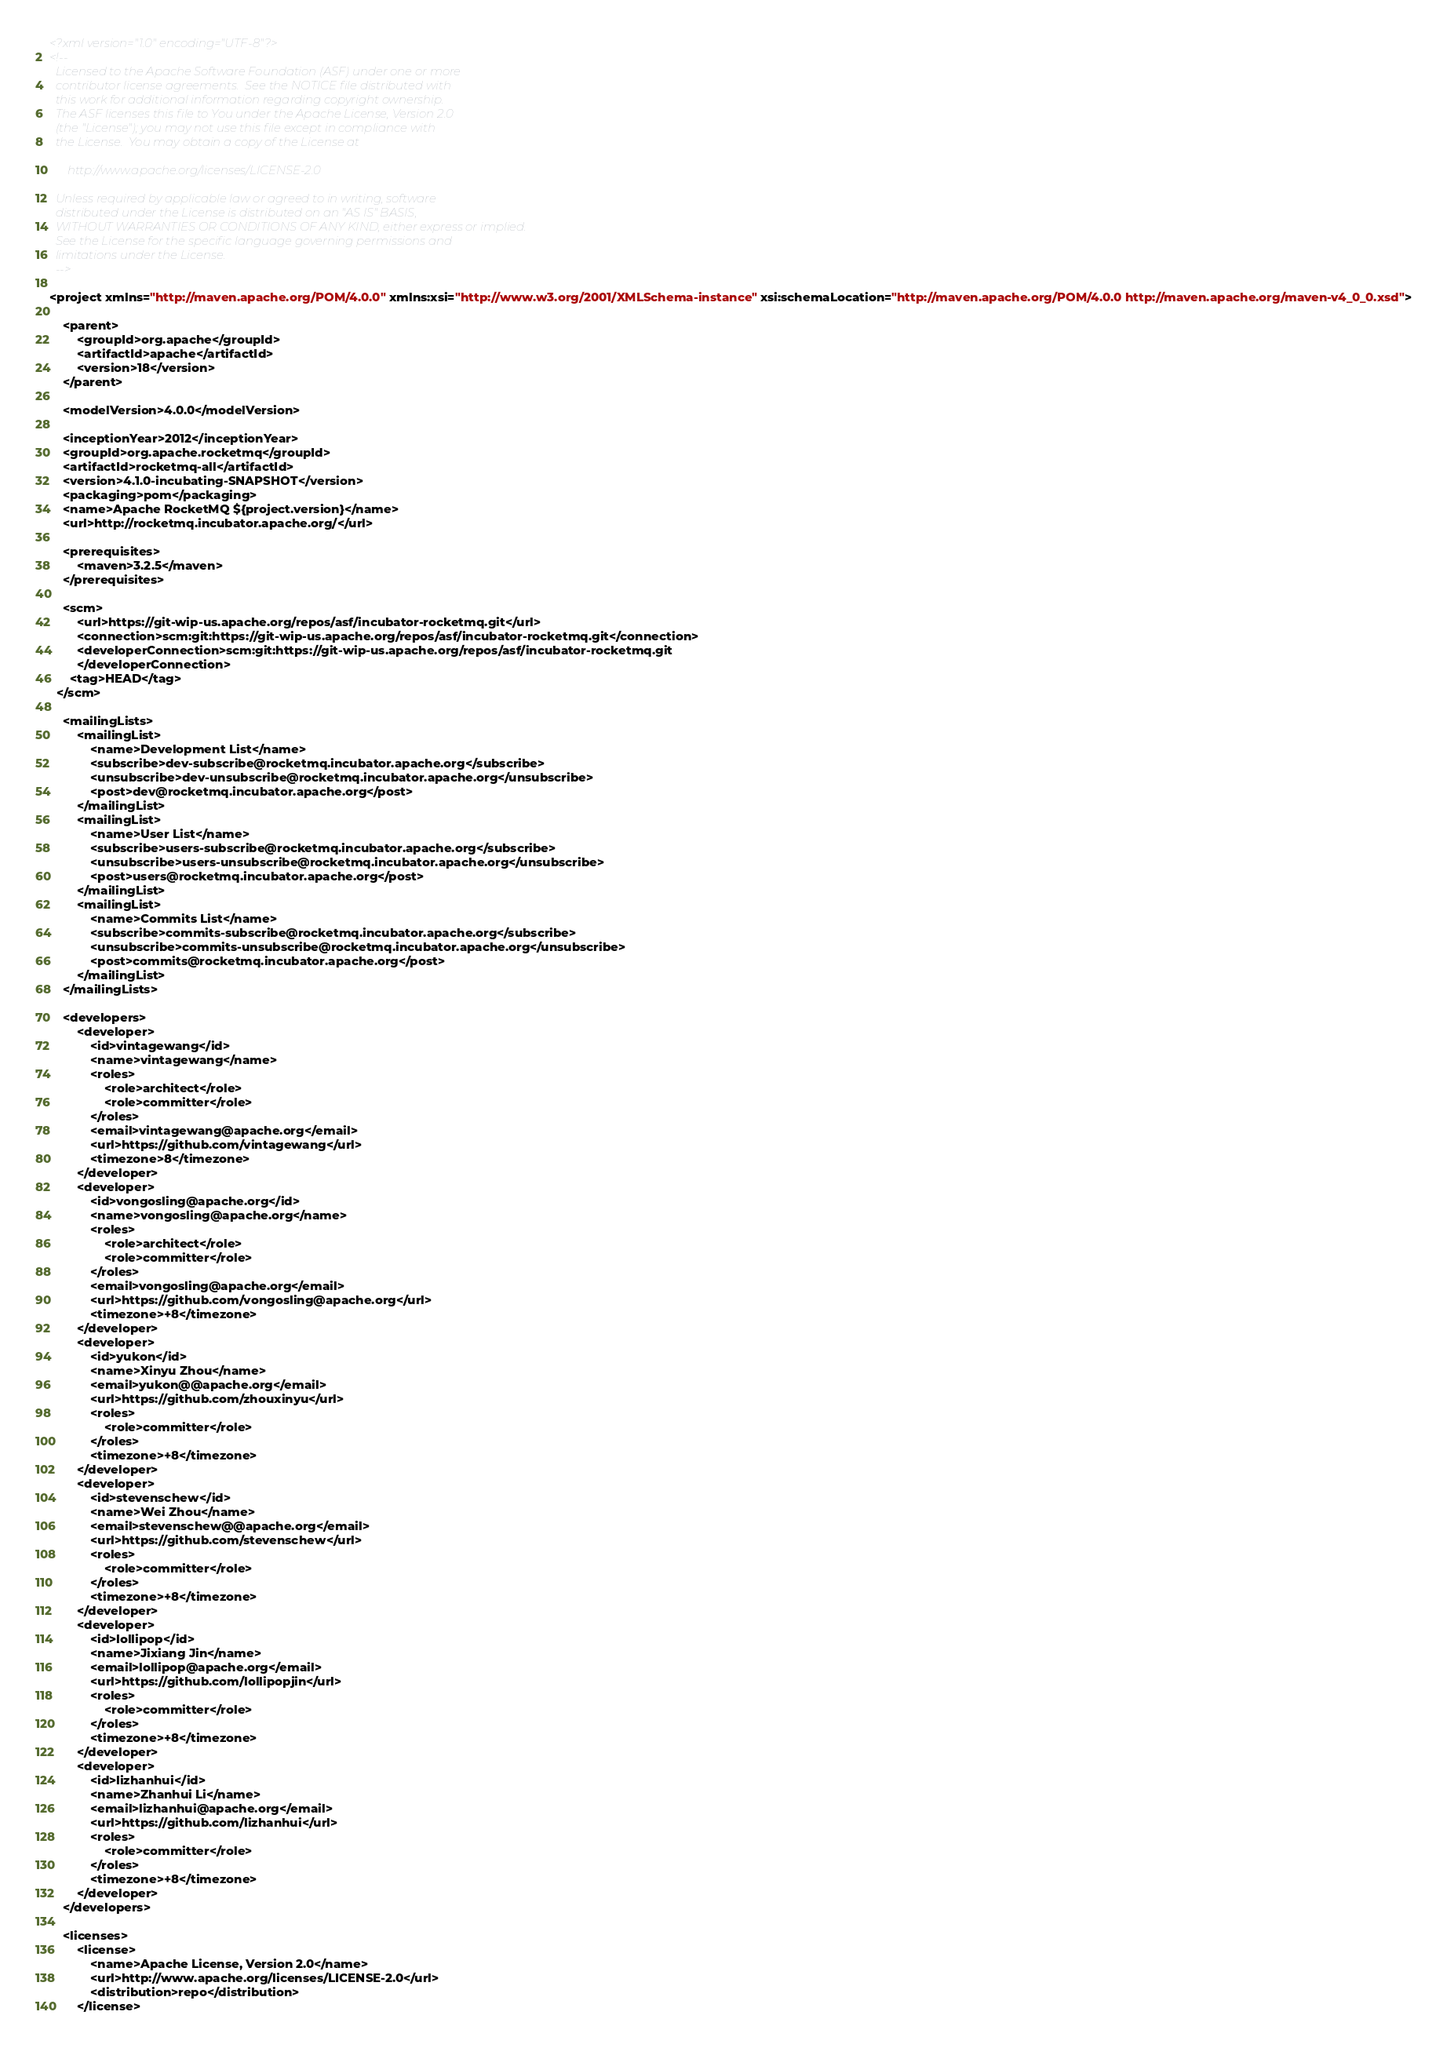Convert code to text. <code><loc_0><loc_0><loc_500><loc_500><_XML_><?xml version="1.0" encoding="UTF-8"?>
<!--
  Licensed to the Apache Software Foundation (ASF) under one or more
  contributor license agreements.  See the NOTICE file distributed with
  this work for additional information regarding copyright ownership.
  The ASF licenses this file to You under the Apache License, Version 2.0
  (the "License"); you may not use this file except in compliance with
  the License.  You may obtain a copy of the License at

      http://www.apache.org/licenses/LICENSE-2.0

  Unless required by applicable law or agreed to in writing, software
  distributed under the License is distributed on an "AS IS" BASIS,
  WITHOUT WARRANTIES OR CONDITIONS OF ANY KIND, either express or implied.
  See the License for the specific language governing permissions and
  limitations under the License.
  -->

<project xmlns="http://maven.apache.org/POM/4.0.0" xmlns:xsi="http://www.w3.org/2001/XMLSchema-instance" xsi:schemaLocation="http://maven.apache.org/POM/4.0.0 http://maven.apache.org/maven-v4_0_0.xsd">

    <parent>
        <groupId>org.apache</groupId>
        <artifactId>apache</artifactId>
        <version>18</version>
    </parent>

    <modelVersion>4.0.0</modelVersion>

    <inceptionYear>2012</inceptionYear>
    <groupId>org.apache.rocketmq</groupId>
    <artifactId>rocketmq-all</artifactId>
    <version>4.1.0-incubating-SNAPSHOT</version>
    <packaging>pom</packaging>
    <name>Apache RocketMQ ${project.version}</name>
    <url>http://rocketmq.incubator.apache.org/</url>

    <prerequisites>
        <maven>3.2.5</maven>
    </prerequisites>

    <scm>
        <url>https://git-wip-us.apache.org/repos/asf/incubator-rocketmq.git</url>
        <connection>scm:git:https://git-wip-us.apache.org/repos/asf/incubator-rocketmq.git</connection>
        <developerConnection>scm:git:https://git-wip-us.apache.org/repos/asf/incubator-rocketmq.git
        </developerConnection>
      <tag>HEAD</tag>
  </scm>

    <mailingLists>
        <mailingList>
            <name>Development List</name>
            <subscribe>dev-subscribe@rocketmq.incubator.apache.org</subscribe>
            <unsubscribe>dev-unsubscribe@rocketmq.incubator.apache.org</unsubscribe>
            <post>dev@rocketmq.incubator.apache.org</post>
        </mailingList>
        <mailingList>
            <name>User List</name>
            <subscribe>users-subscribe@rocketmq.incubator.apache.org</subscribe>
            <unsubscribe>users-unsubscribe@rocketmq.incubator.apache.org</unsubscribe>
            <post>users@rocketmq.incubator.apache.org</post>
        </mailingList>
        <mailingList>
            <name>Commits List</name>
            <subscribe>commits-subscribe@rocketmq.incubator.apache.org</subscribe>
            <unsubscribe>commits-unsubscribe@rocketmq.incubator.apache.org</unsubscribe>
            <post>commits@rocketmq.incubator.apache.org</post>
        </mailingList>
    </mailingLists>

    <developers>
        <developer>
            <id>vintagewang</id>
            <name>vintagewang</name>
            <roles>
                <role>architect</role>
                <role>committer</role>
            </roles>
            <email>vintagewang@apache.org</email>
            <url>https://github.com/vintagewang</url>
            <timezone>8</timezone>
        </developer>
        <developer>
            <id>vongosling@apache.org</id>
            <name>vongosling@apache.org</name>
            <roles>
                <role>architect</role>
                <role>committer</role>
            </roles>
            <email>vongosling@apache.org</email>
            <url>https://github.com/vongosling@apache.org</url>
            <timezone>+8</timezone>
        </developer>
        <developer>
            <id>yukon</id>
            <name>Xinyu Zhou</name>
            <email>yukon@@apache.org</email>
            <url>https://github.com/zhouxinyu</url>
            <roles>
                <role>committer</role>
            </roles>
            <timezone>+8</timezone>
        </developer>
        <developer>
            <id>stevenschew</id>
            <name>Wei Zhou</name>
            <email>stevenschew@@apache.org</email>
            <url>https://github.com/stevenschew</url>
            <roles>
                <role>committer</role>
            </roles>
            <timezone>+8</timezone>
        </developer>
        <developer>
            <id>lollipop</id>
            <name>Jixiang Jin</name>
            <email>lollipop@apache.org</email>
            <url>https://github.com/lollipopjin</url>
            <roles>
                <role>committer</role>
            </roles>
            <timezone>+8</timezone>
        </developer>
        <developer>
            <id>lizhanhui</id>
            <name>Zhanhui Li</name>
            <email>lizhanhui@apache.org</email>
            <url>https://github.com/lizhanhui</url>
            <roles>
                <role>committer</role>
            </roles>
            <timezone>+8</timezone>
        </developer>
    </developers>

    <licenses>
        <license>
            <name>Apache License, Version 2.0</name>
            <url>http://www.apache.org/licenses/LICENSE-2.0</url>
            <distribution>repo</distribution>
        </license></code> 